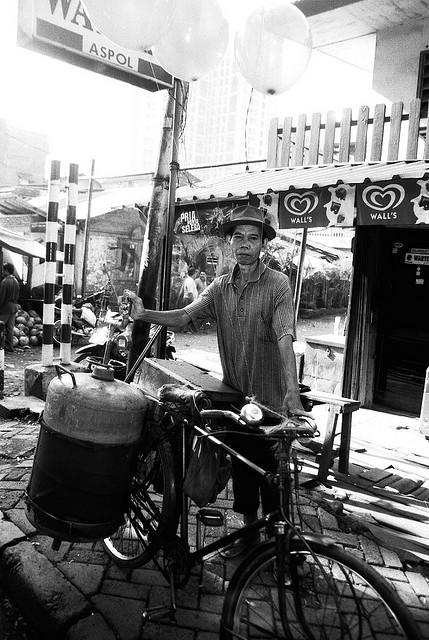What is the shape of the Wall's logo?

Choices:
A) circle
B) square
C) heart
D) triangle heart 